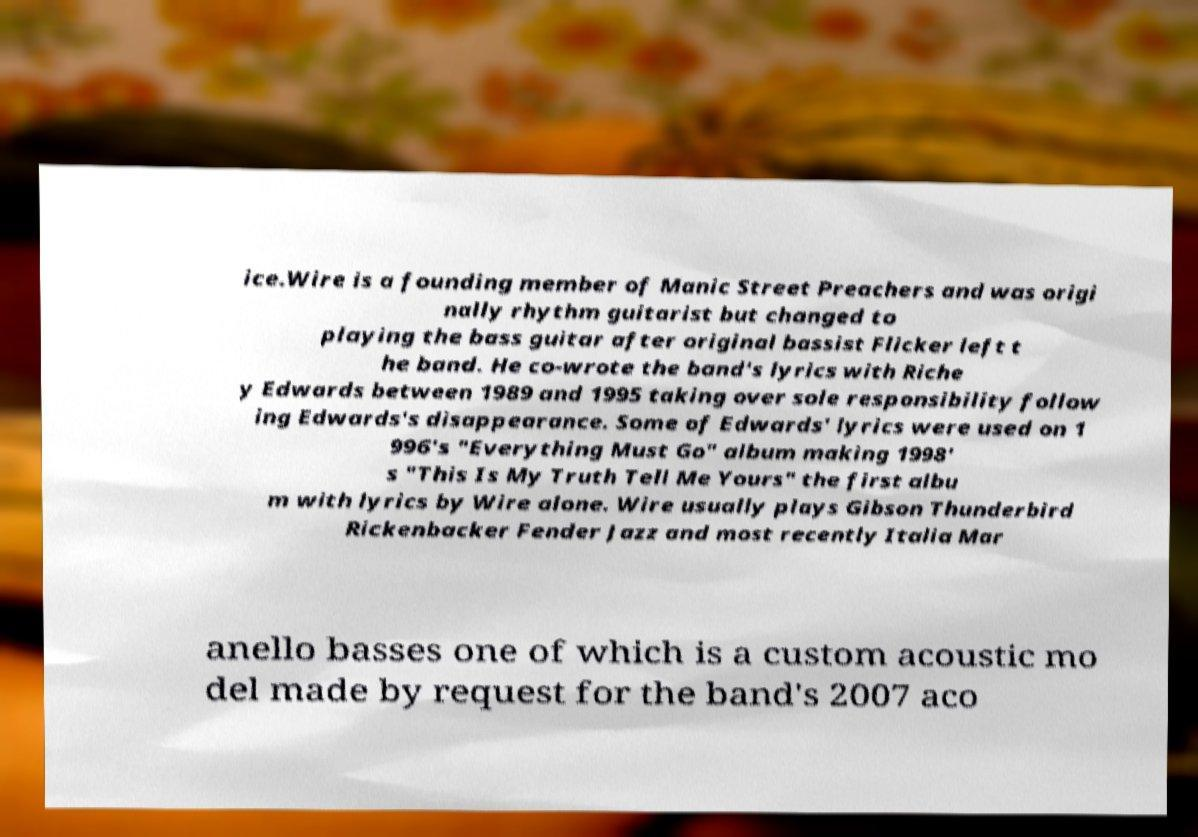Could you assist in decoding the text presented in this image and type it out clearly? ice.Wire is a founding member of Manic Street Preachers and was origi nally rhythm guitarist but changed to playing the bass guitar after original bassist Flicker left t he band. He co-wrote the band's lyrics with Riche y Edwards between 1989 and 1995 taking over sole responsibility follow ing Edwards's disappearance. Some of Edwards' lyrics were used on 1 996's "Everything Must Go" album making 1998' s "This Is My Truth Tell Me Yours" the first albu m with lyrics by Wire alone. Wire usually plays Gibson Thunderbird Rickenbacker Fender Jazz and most recently Italia Mar anello basses one of which is a custom acoustic mo del made by request for the band's 2007 aco 